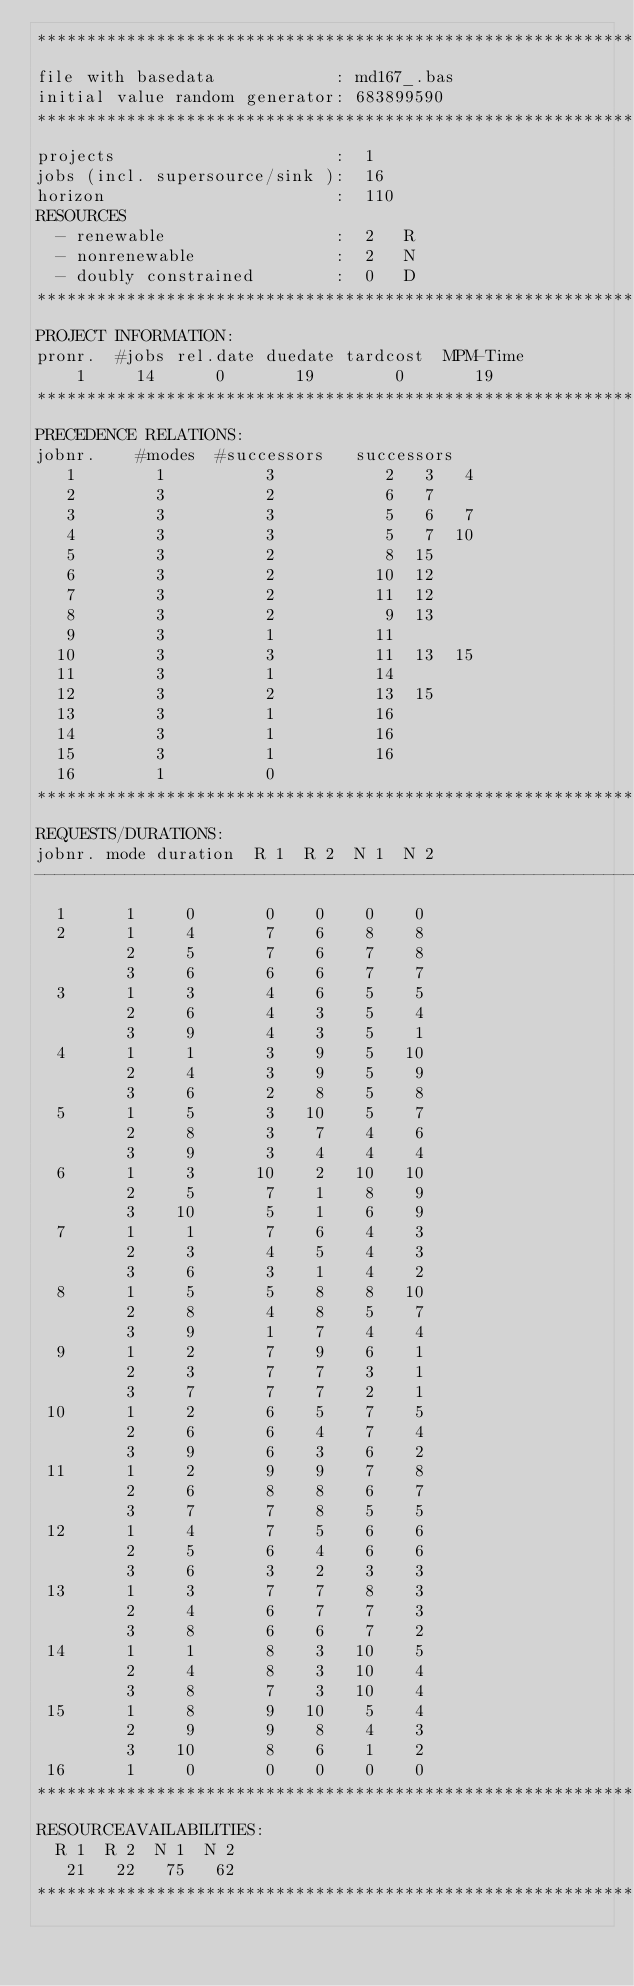Convert code to text. <code><loc_0><loc_0><loc_500><loc_500><_ObjectiveC_>************************************************************************
file with basedata            : md167_.bas
initial value random generator: 683899590
************************************************************************
projects                      :  1
jobs (incl. supersource/sink ):  16
horizon                       :  110
RESOURCES
  - renewable                 :  2   R
  - nonrenewable              :  2   N
  - doubly constrained        :  0   D
************************************************************************
PROJECT INFORMATION:
pronr.  #jobs rel.date duedate tardcost  MPM-Time
    1     14      0       19        0       19
************************************************************************
PRECEDENCE RELATIONS:
jobnr.    #modes  #successors   successors
   1        1          3           2   3   4
   2        3          2           6   7
   3        3          3           5   6   7
   4        3          3           5   7  10
   5        3          2           8  15
   6        3          2          10  12
   7        3          2          11  12
   8        3          2           9  13
   9        3          1          11
  10        3          3          11  13  15
  11        3          1          14
  12        3          2          13  15
  13        3          1          16
  14        3          1          16
  15        3          1          16
  16        1          0        
************************************************************************
REQUESTS/DURATIONS:
jobnr. mode duration  R 1  R 2  N 1  N 2
------------------------------------------------------------------------
  1      1     0       0    0    0    0
  2      1     4       7    6    8    8
         2     5       7    6    7    8
         3     6       6    6    7    7
  3      1     3       4    6    5    5
         2     6       4    3    5    4
         3     9       4    3    5    1
  4      1     1       3    9    5   10
         2     4       3    9    5    9
         3     6       2    8    5    8
  5      1     5       3   10    5    7
         2     8       3    7    4    6
         3     9       3    4    4    4
  6      1     3      10    2   10   10
         2     5       7    1    8    9
         3    10       5    1    6    9
  7      1     1       7    6    4    3
         2     3       4    5    4    3
         3     6       3    1    4    2
  8      1     5       5    8    8   10
         2     8       4    8    5    7
         3     9       1    7    4    4
  9      1     2       7    9    6    1
         2     3       7    7    3    1
         3     7       7    7    2    1
 10      1     2       6    5    7    5
         2     6       6    4    7    4
         3     9       6    3    6    2
 11      1     2       9    9    7    8
         2     6       8    8    6    7
         3     7       7    8    5    5
 12      1     4       7    5    6    6
         2     5       6    4    6    6
         3     6       3    2    3    3
 13      1     3       7    7    8    3
         2     4       6    7    7    3
         3     8       6    6    7    2
 14      1     1       8    3   10    5
         2     4       8    3   10    4
         3     8       7    3   10    4
 15      1     8       9   10    5    4
         2     9       9    8    4    3
         3    10       8    6    1    2
 16      1     0       0    0    0    0
************************************************************************
RESOURCEAVAILABILITIES:
  R 1  R 2  N 1  N 2
   21   22   75   62
************************************************************************
</code> 